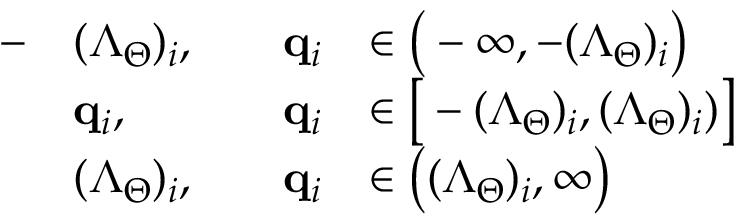Convert formula to latex. <formula><loc_0><loc_0><loc_500><loc_500>\begin{array} { r l r l } { - } & { ( \Lambda _ { \Theta } ) _ { i } , \quad } & { q _ { i } } & { \in \left ( - \infty , - ( \Lambda _ { \Theta } ) _ { i } \right ) } \\ & { q _ { i } , \quad } & { q _ { i } } & { \in \left [ - ( \Lambda _ { \Theta } ) _ { i } , ( \Lambda _ { \Theta } ) _ { i } ) \right ] } \\ & { ( \Lambda _ { \Theta } ) _ { i } , } & { q _ { i } } & { \in \left ( ( \Lambda _ { \Theta } ) _ { i } , \infty \right ) } \end{array}</formula> 